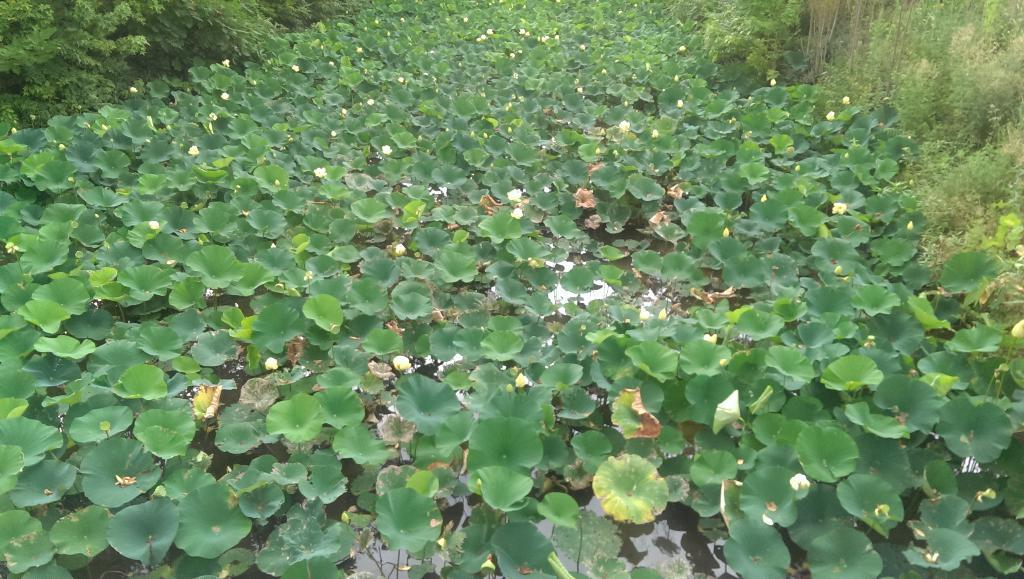What is located in the center of the image? There are water plants in the center of the image. What can be seen on both sides of the image? There are plants on both sides of the image. What type of glass is used to hold the water plants in the image? There is no glass present in the image; the water plants are directly in the water. How does the image demonstrate the process of digestion? The image does not demonstrate the process of digestion; it features water plants and other plants. 